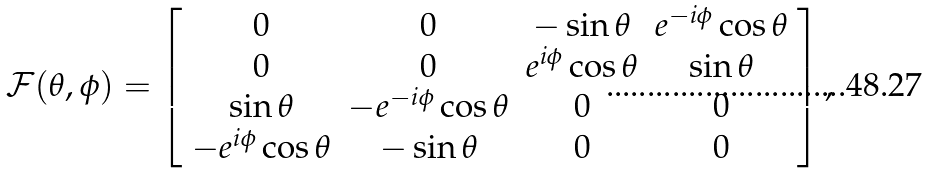Convert formula to latex. <formula><loc_0><loc_0><loc_500><loc_500>\mathcal { F } ( \theta , \phi ) = \left [ \begin{array} { c c c c } 0 & 0 & - \sin \theta & e ^ { - i \phi } \cos \theta \\ 0 & 0 & e ^ { i \phi } \cos \theta & \sin \theta \\ \sin \theta & - e ^ { - i \phi } \cos \theta & 0 & 0 \\ - e ^ { i \phi } \cos \theta & - \sin \theta & 0 & 0 \\ \end{array} \right ] ,</formula> 